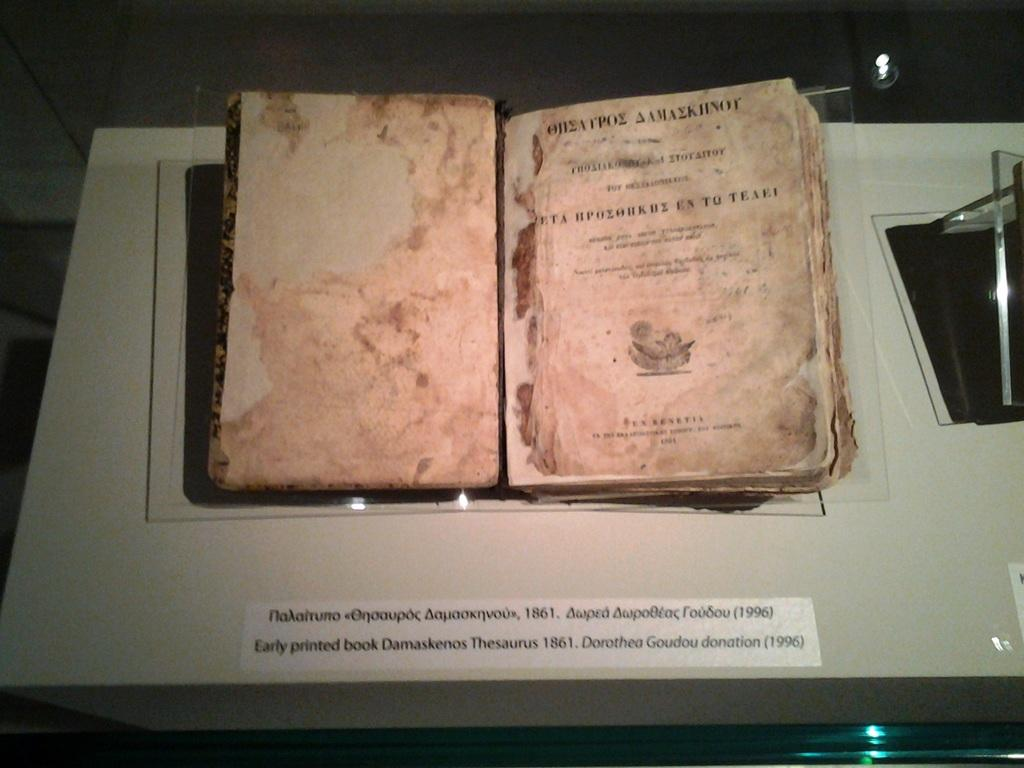What object can be seen in the image? There is a book in the image. What is written on the book? The book has text written on it. What can be seen at the top of the image? There is a light visible at the top of the image. What type of relation does the mom have with the book in the image? There is no mom present in the image, so it is not possible to determine any relation with the book. 